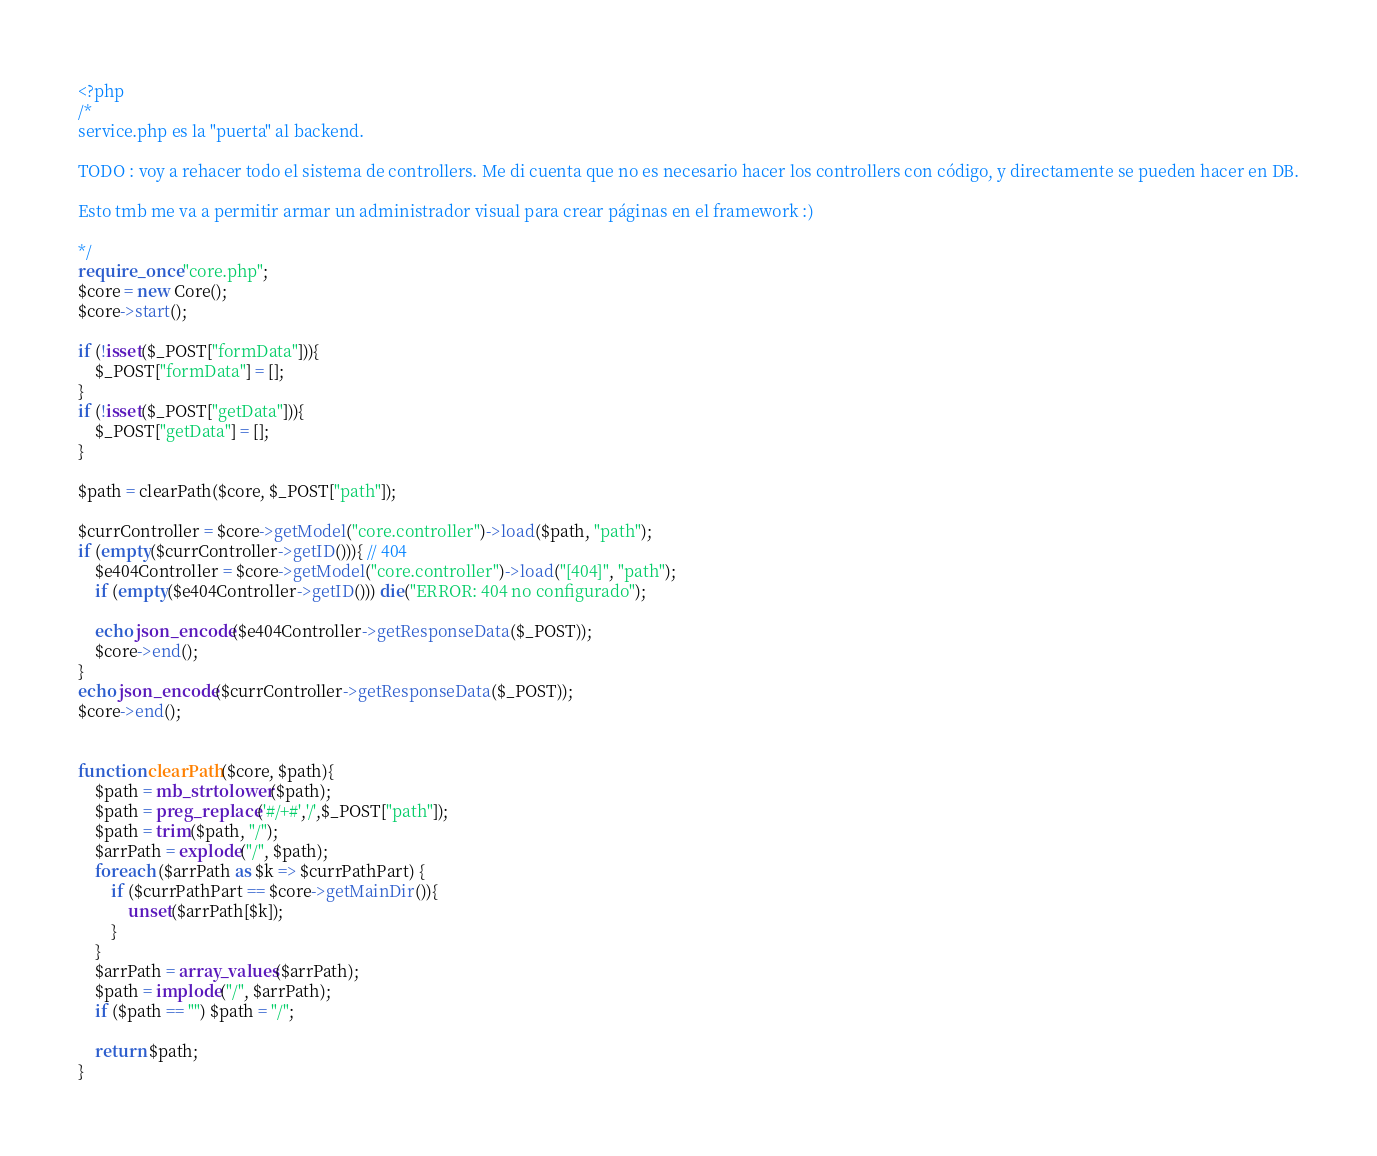<code> <loc_0><loc_0><loc_500><loc_500><_PHP_><?php 
/*
service.php es la "puerta" al backend.

TODO : voy a rehacer todo el sistema de controllers. Me di cuenta que no es necesario hacer los controllers con código, y directamente se pueden hacer en DB.

Esto tmb me va a permitir armar un administrador visual para crear páginas en el framework :)

*/
require_once "core.php";
$core = new Core();
$core->start();

if (!isset($_POST["formData"])){
	$_POST["formData"] = [];
}
if (!isset($_POST["getData"])){
	$_POST["getData"] = [];
}

$path = clearPath($core, $_POST["path"]);

$currController = $core->getModel("core.controller")->load($path, "path");
if (empty($currController->getID())){ // 404
	$e404Controller = $core->getModel("core.controller")->load("[404]", "path");
	if (empty($e404Controller->getID())) die("ERROR: 404 no configurado");

	echo json_encode($e404Controller->getResponseData($_POST));
	$core->end();
}
echo json_encode($currController->getResponseData($_POST));
$core->end();


function clearPath($core, $path){
	$path = mb_strtolower($path);
	$path = preg_replace('#/+#','/',$_POST["path"]);
	$path = trim($path, "/");
	$arrPath = explode("/", $path);
	foreach ($arrPath as $k => $currPathPart) {
		if ($currPathPart == $core->getMainDir()){
			unset($arrPath[$k]);
		}
	}
	$arrPath = array_values($arrPath);
	$path = implode("/", $arrPath);
	if ($path == "") $path = "/";

	return $path;
}</code> 